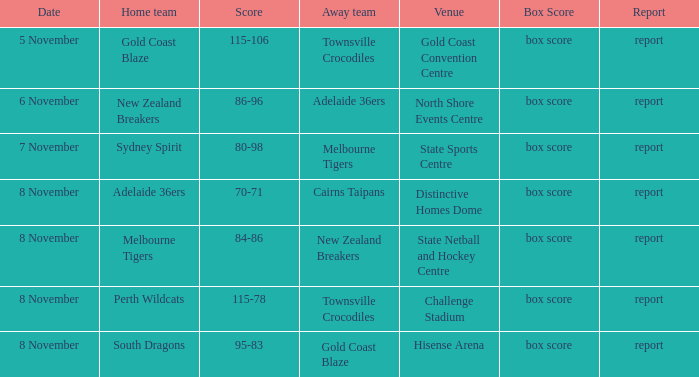What was the date when a contest with gold coast blaze took place? 8 November. 